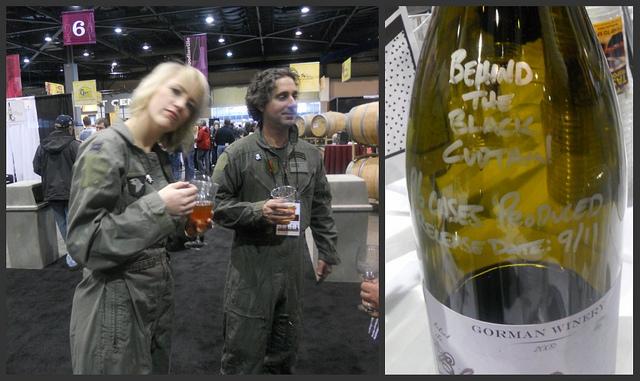What is the color of the woman's hair?
Give a very brief answer. Blonde. What mood do you think the woman is in?
Concise answer only. Happy. Is the blonde tilting her head?
Write a very short answer. Yes. What is written on the wine bottle?
Short answer required. Behind black curtain. 